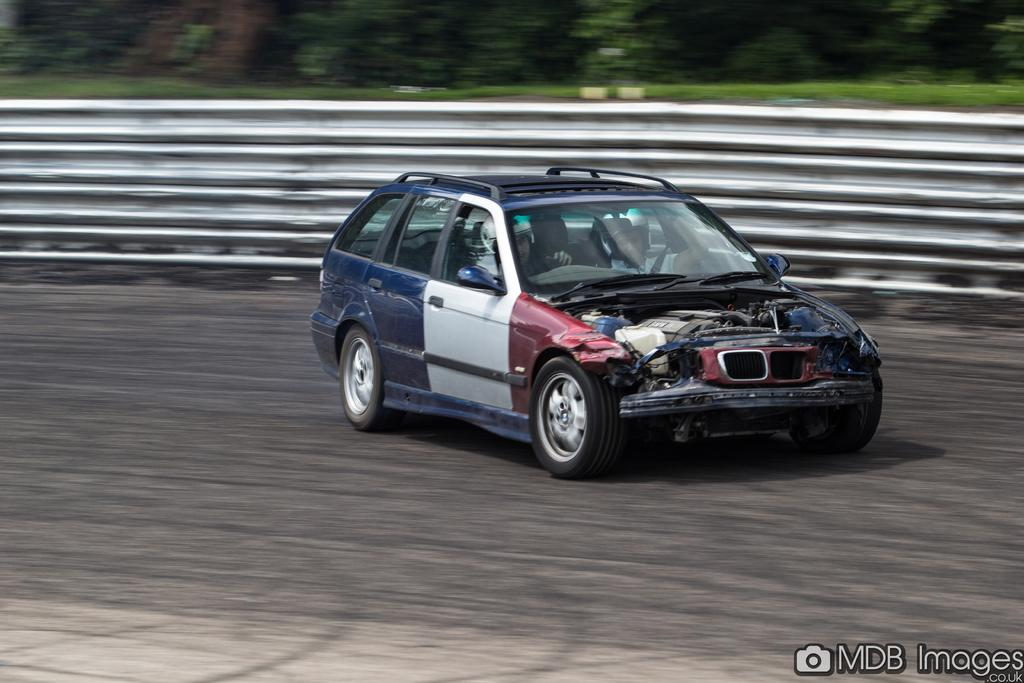How many people are in the car in the image? There are two persons in a car in the image. What is the location of the car in the image? The car is on the road in the image. What can be seen alongside the road in the image? There are guard rails in the image. What is visible in the background of the image? There are trees in the background of the image. What type of holiday is being celebrated in the car in the image? There is no indication of a holiday being celebrated in the car or the image. What is located at the back of the car in the image? The back of the car is not visible in the image, as it only shows the front of the vehicle. 